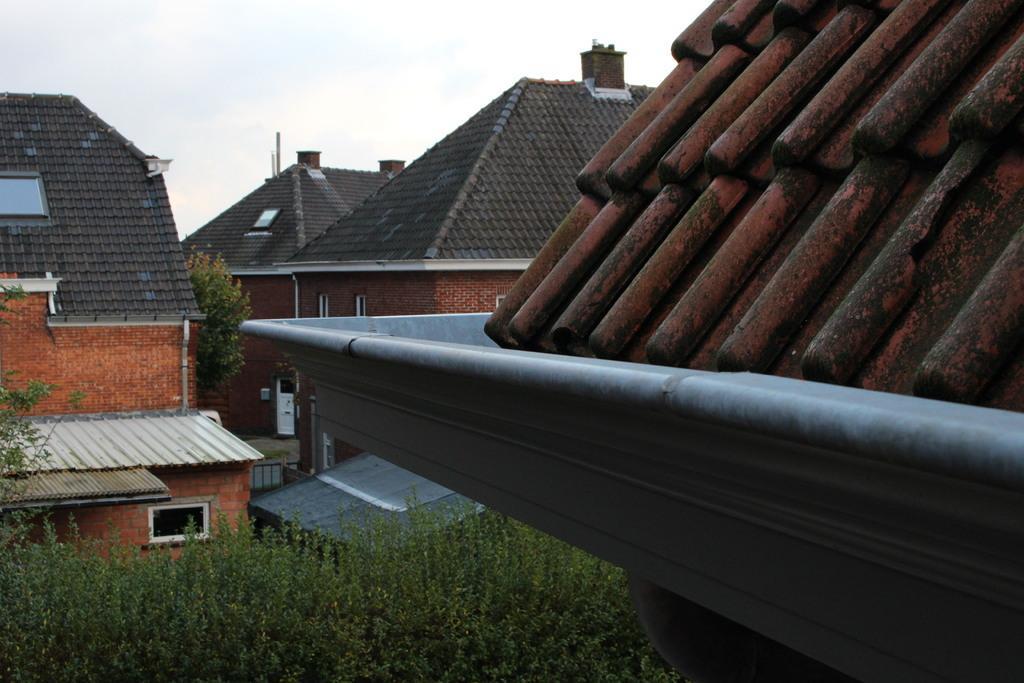How would you summarize this image in a sentence or two? In this image we can see group of buildings ,roof tiles ,plants and in the background we can see the sky. 